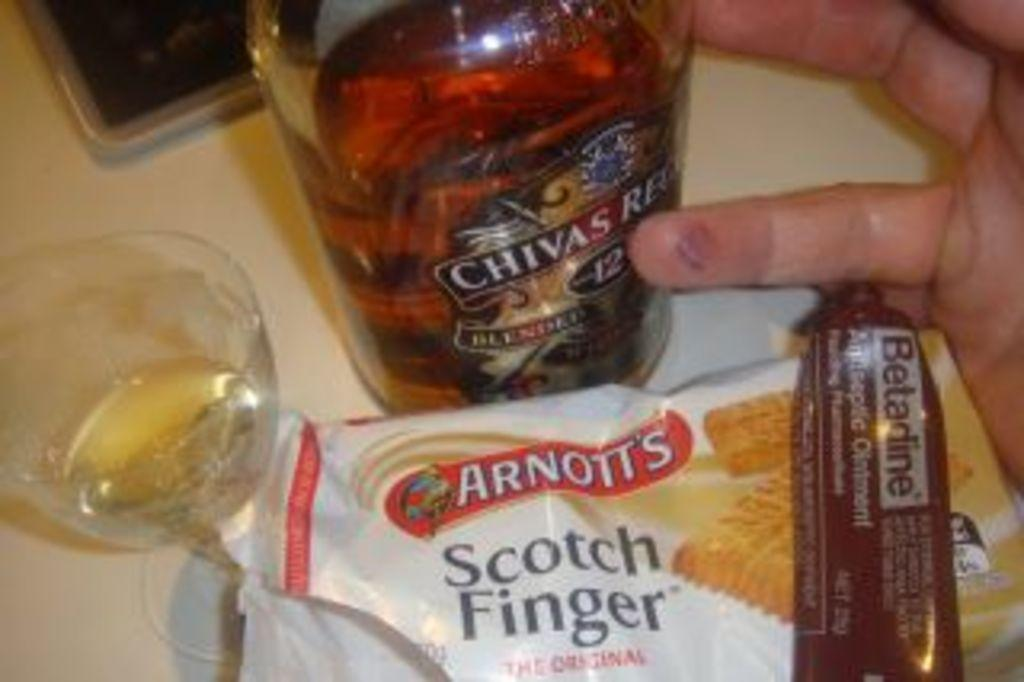<image>
Write a terse but informative summary of the picture. Bottle with a label that says "CHIVAS" on it. 